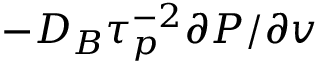Convert formula to latex. <formula><loc_0><loc_0><loc_500><loc_500>- D _ { B } \tau _ { p } ^ { - 2 } \partial P / \partial v</formula> 